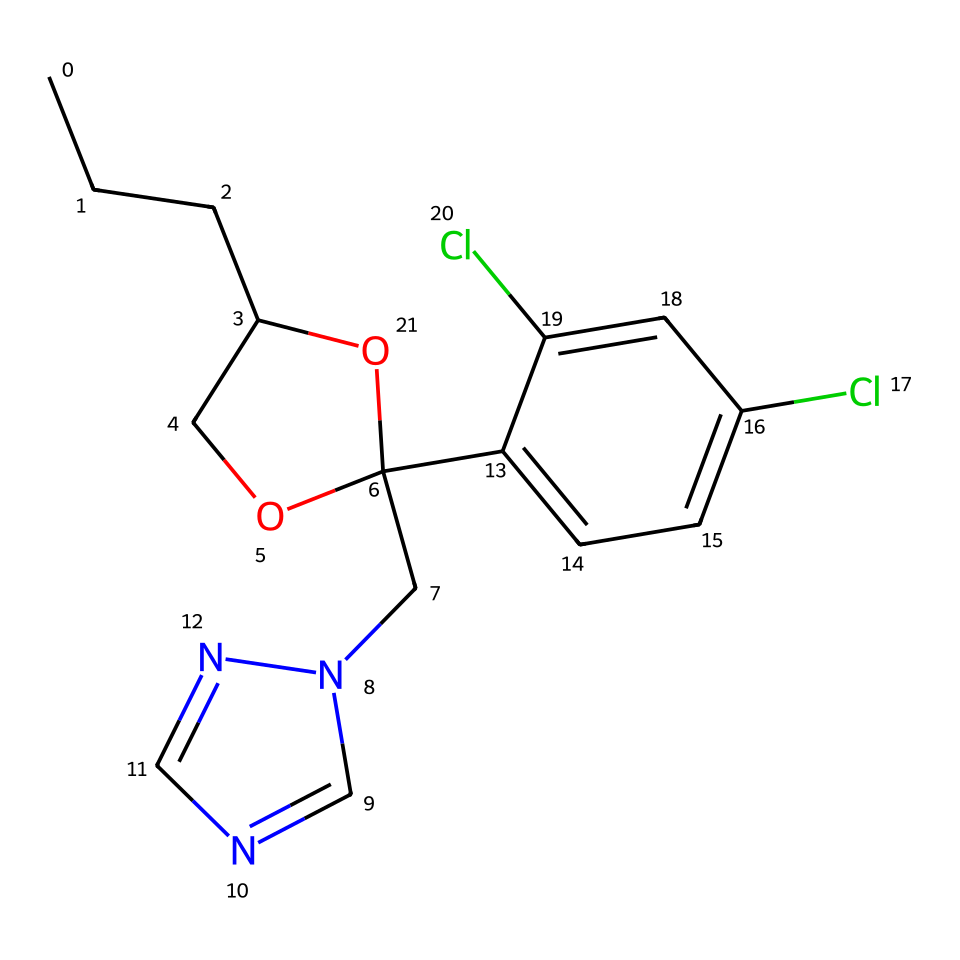What is the main functional group in propiconazole? The structure includes a hydroxyl group (–OH), which is indicative of its alcohol functionality, classified under functional groups.
Answer: hydroxyl How many nitrogen atoms are present in propiconazole? By inspecting the chemical structure, we identify two distinct nitrogen atoms from the ring structures found in the compound.
Answer: 2 What is the number of chlorine substituents in propiconazole? The chemical contains two chlorine (Cl) atoms, demonstrated by their presence as substituents on the aromatic ring portion of the structure.
Answer: 2 Does propiconazole feature an aromatic system? Yes, the compound contains a benzene ring, which is characterized by alternating double bonds and is evident in the overall arrangement.
Answer: yes What type of chemical is propiconazole categorized as? Based on its function and structural properties, propiconazole is categorized as a triazole fungicide, which is recognized for its role in agriculture.
Answer: triazole fungicide 